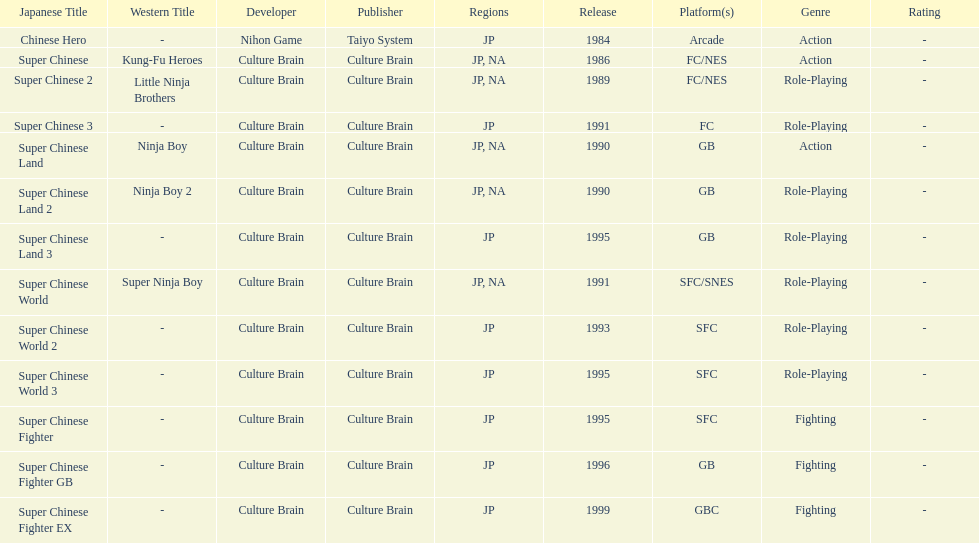Number of super chinese world games released 3. 